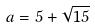<formula> <loc_0><loc_0><loc_500><loc_500>a = 5 + \sqrt { 1 5 }</formula> 